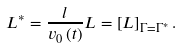<formula> <loc_0><loc_0><loc_500><loc_500>L ^ { \ast } = \frac { l } { v _ { 0 } \left ( t \right ) } L = \left [ L \right ] _ { \Gamma = \Gamma ^ { \ast } } .</formula> 